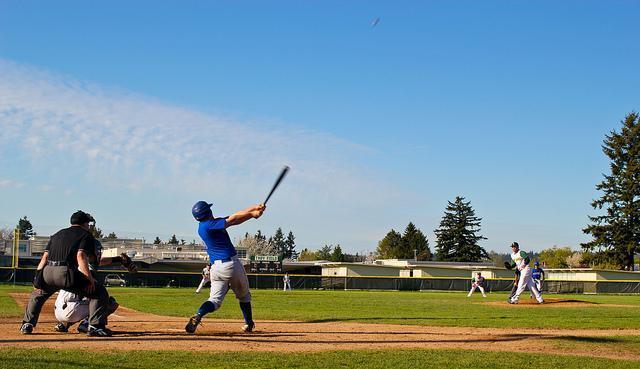How many people are in the photo?
Give a very brief answer. 2. How many food poles for the giraffes are there?
Give a very brief answer. 0. 